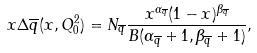<formula> <loc_0><loc_0><loc_500><loc_500>x \Delta \overline { q } ( x , Q _ { 0 } ^ { 2 } ) = N _ { \overline { q } } \frac { x ^ { \alpha _ { \overline { q } } } ( 1 - x ) ^ { \beta _ { \overline { q } } } } { B ( \alpha _ { \overline { q } } + 1 , \beta _ { \overline { q } } + 1 ) } ,</formula> 